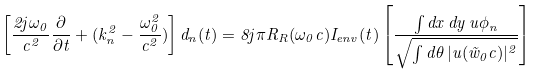<formula> <loc_0><loc_0><loc_500><loc_500>\left [ \frac { 2 j \omega _ { 0 } } { c ^ { 2 } } \frac { \partial } { \partial t } + ( k _ { n } ^ { 2 } - \frac { \omega _ { 0 } ^ { 2 } } { c ^ { 2 } } ) \right ] d _ { n } ( t ) = 8 j \pi R _ { R } ( \omega _ { 0 } c ) I _ { e n v } ( t ) \left [ \frac { \int d x \, d y \, u \phi _ { n } } { \sqrt { \int d \theta \, | u ( \vec { w } _ { 0 } c ) | ^ { 2 } } } \right ]</formula> 